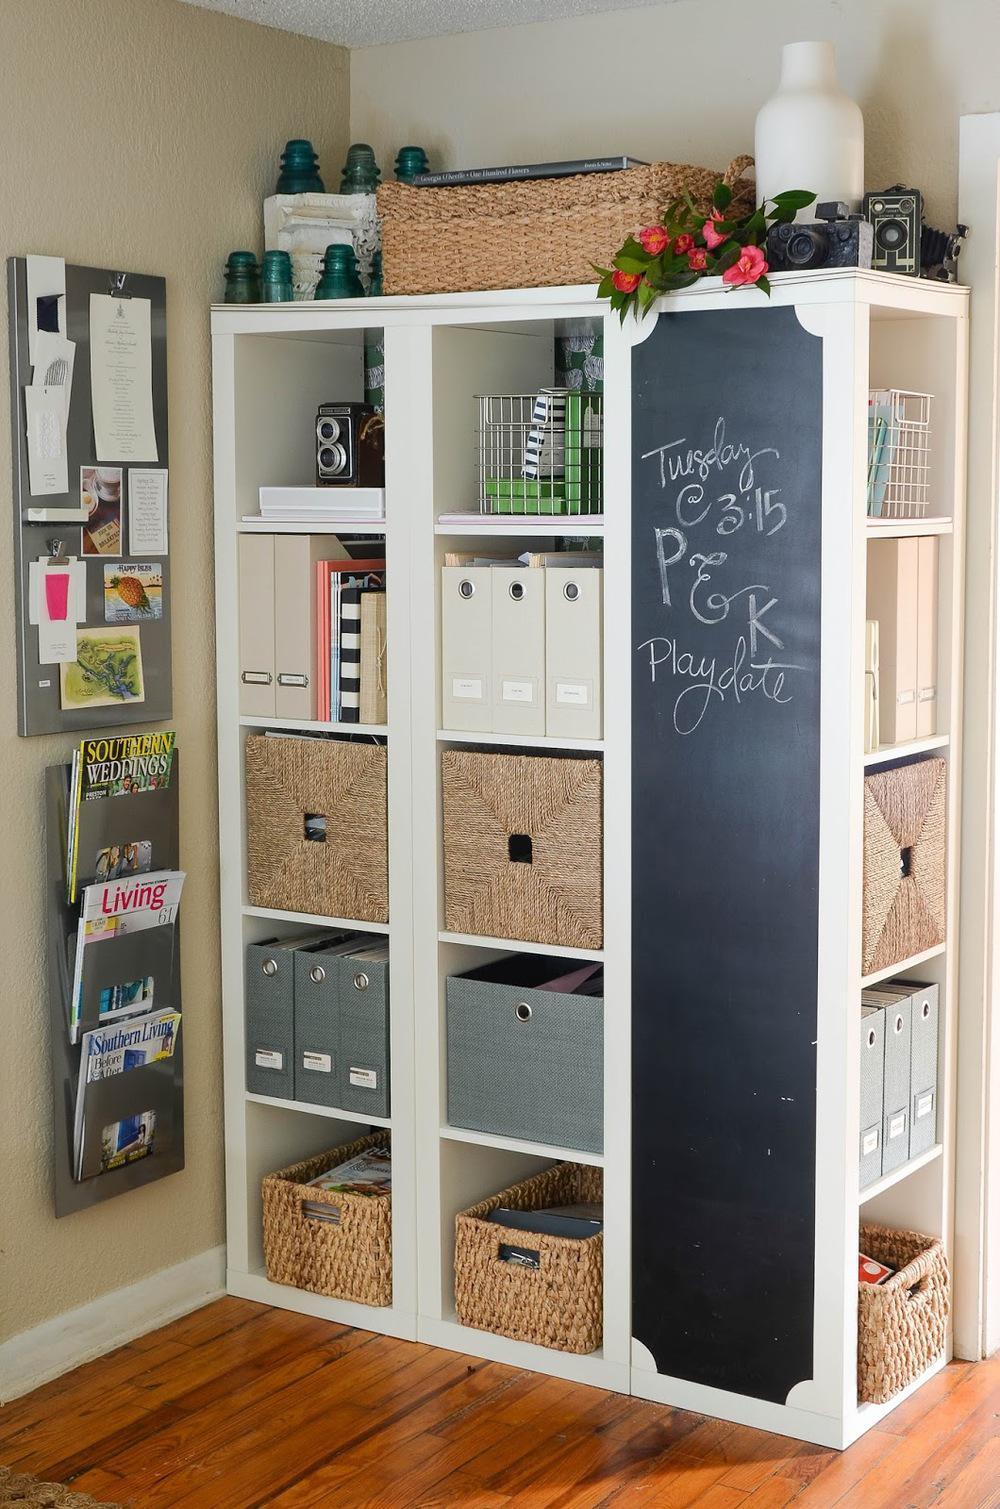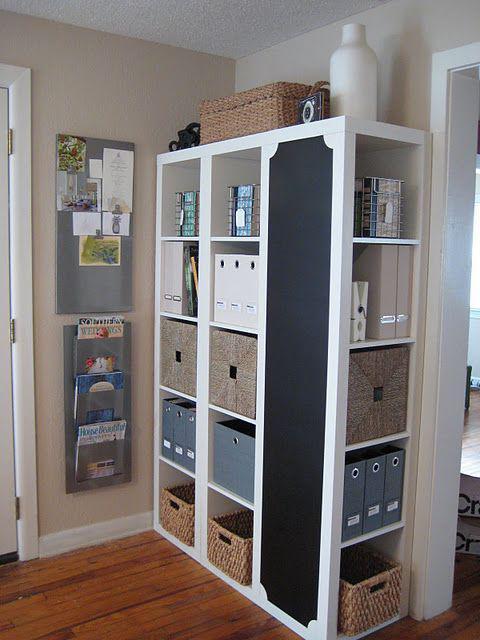The first image is the image on the left, the second image is the image on the right. Assess this claim about the two images: "One of the bookcases show is adjacent to some windows.". Correct or not? Answer yes or no. No. The first image is the image on the left, the second image is the image on the right. Examine the images to the left and right. Is the description "there is a white shelving unit with two whicker cubby boxes on the bottom row and a chalk board on the right" accurate? Answer yes or no. Yes. 